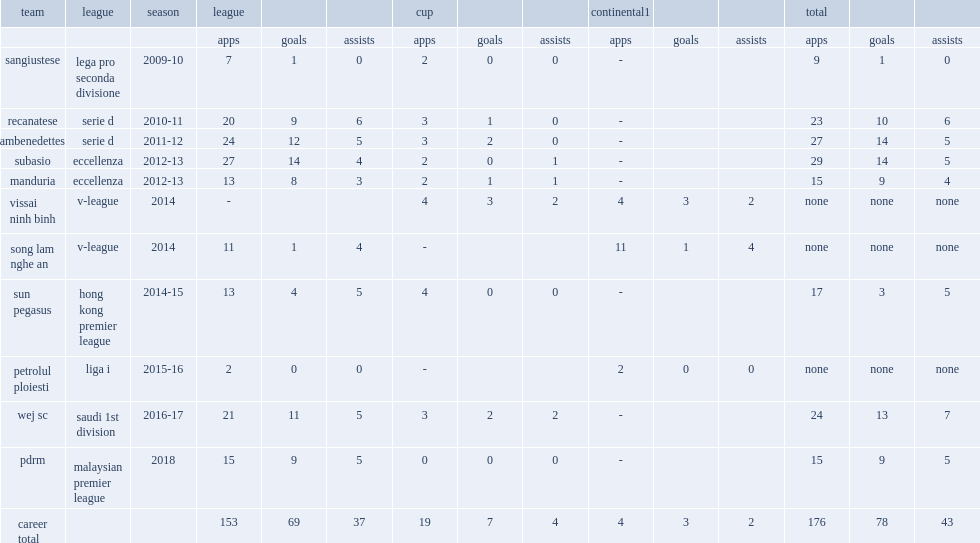When did petrisor appeare for vissai ninh binh in the v-league? 2014.0. 